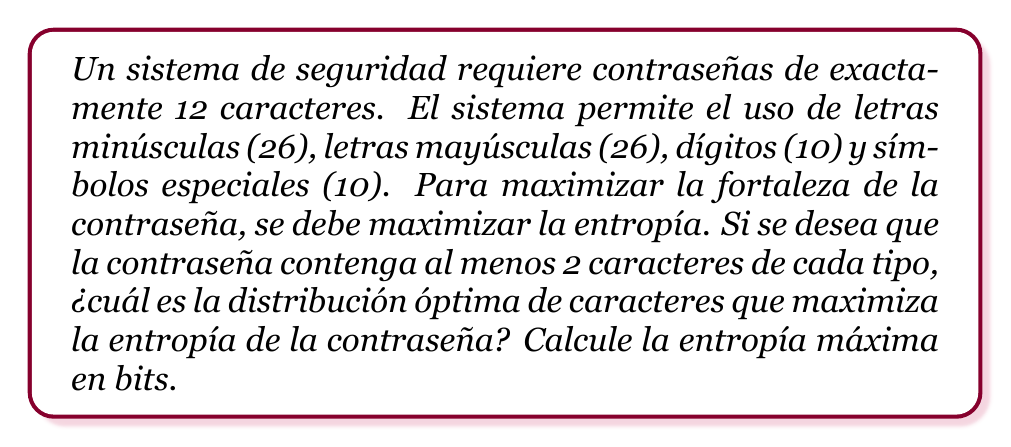Help me with this question. Para resolver este problema, seguiremos estos pasos:

1) La entropía de una contraseña se calcula como:

   $$H = L \log_2(N)$$

   Donde $L$ es la longitud de la contraseña y $N$ es el número de caracteres posibles.

2) En este caso, $L = 12$ y $N = 26 + 26 + 10 + 10 = 72$ caracteres posibles en total.

3) Para maximizar la entropía, debemos distribuir los caracteres de manera uniforme entre los cuatro tipos. Sin embargo, tenemos la restricción de usar al menos 2 de cada tipo.

4) La distribución óptima sería:
   - 3 letras minúsculas
   - 3 letras mayúsculas
   - 3 dígitos
   - 3 símbolos especiales

5) Con esta distribución, calculamos la entropía:

   $$H = 12 \log_2(72) = 12 * 6.17 = 74.04$$ bits

6) Verificamos que esta distribución es óptima:
   - Si movemos un carácter de un grupo a otro, la entropía disminuiría porque la distribución sería menos uniforme.
   - No podemos reducir ningún grupo a menos de 2 caracteres debido a la restricción dada.

Por lo tanto, esta distribución maximiza la entropía dentro de las restricciones dadas.
Answer: La distribución óptima es: 3 letras minúsculas, 3 letras mayúsculas, 3 dígitos y 3 símbolos especiales. La entropía máxima es 74.04 bits. 